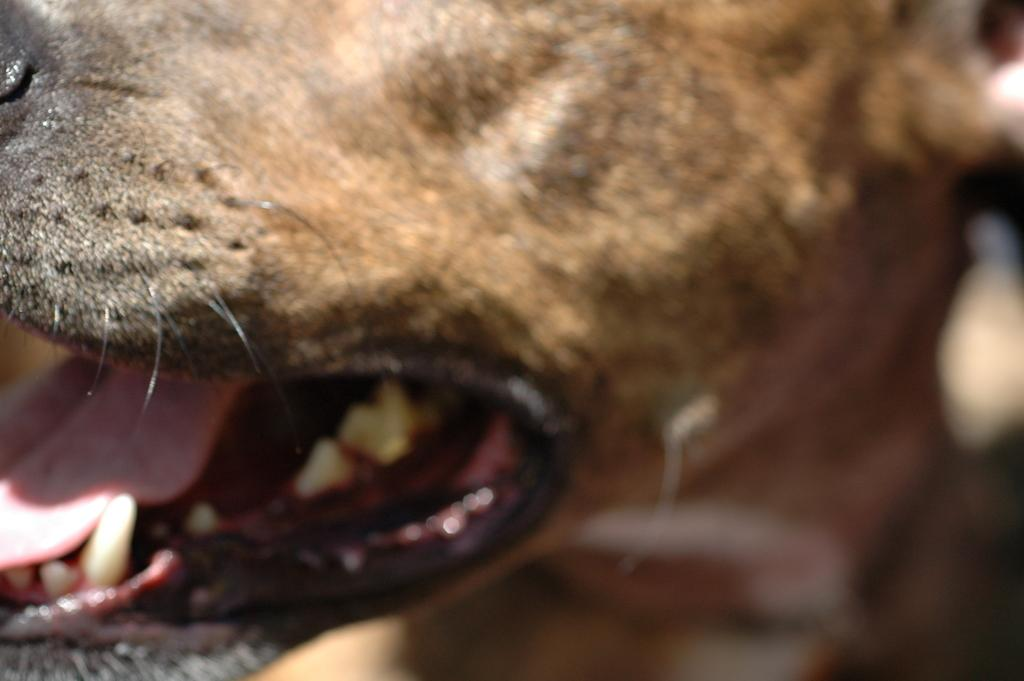What type of animal is in the image? The specific type of animal cannot be determined from the provided facts. What part of the animal's face is visible in the image? The mouth, tongue, and teeth of the animal are visible in the image. Can you describe the animal sounds be heard in the image? The image is silent, so no animal sounds can be heard. How does the animal use thunder to communicate in the image? There is no thunder present in the image, and the animal does not use any form of communication in the image. 